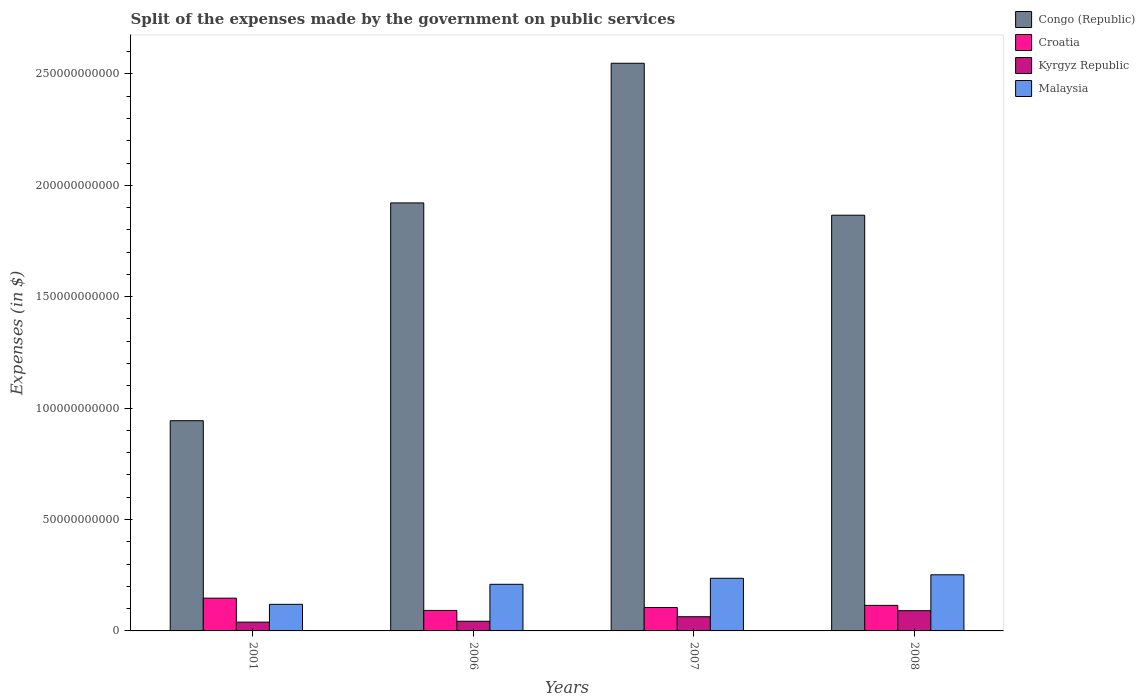Are the number of bars per tick equal to the number of legend labels?
Offer a terse response. Yes. How many bars are there on the 4th tick from the left?
Offer a terse response. 4. How many bars are there on the 2nd tick from the right?
Make the answer very short. 4. What is the expenses made by the government on public services in Congo (Republic) in 2007?
Provide a succinct answer. 2.55e+11. Across all years, what is the maximum expenses made by the government on public services in Malaysia?
Give a very brief answer. 2.52e+1. Across all years, what is the minimum expenses made by the government on public services in Malaysia?
Offer a terse response. 1.19e+1. In which year was the expenses made by the government on public services in Malaysia maximum?
Make the answer very short. 2008. What is the total expenses made by the government on public services in Kyrgyz Republic in the graph?
Provide a succinct answer. 2.37e+1. What is the difference between the expenses made by the government on public services in Congo (Republic) in 2001 and that in 2006?
Give a very brief answer. -9.78e+1. What is the difference between the expenses made by the government on public services in Malaysia in 2001 and the expenses made by the government on public services in Kyrgyz Republic in 2006?
Provide a succinct answer. 7.59e+09. What is the average expenses made by the government on public services in Congo (Republic) per year?
Ensure brevity in your answer.  1.82e+11. In the year 2007, what is the difference between the expenses made by the government on public services in Kyrgyz Republic and expenses made by the government on public services in Congo (Republic)?
Make the answer very short. -2.48e+11. In how many years, is the expenses made by the government on public services in Malaysia greater than 120000000000 $?
Your answer should be compact. 0. What is the ratio of the expenses made by the government on public services in Kyrgyz Republic in 2007 to that in 2008?
Offer a terse response. 0.7. What is the difference between the highest and the second highest expenses made by the government on public services in Kyrgyz Republic?
Offer a very short reply. 2.71e+09. What is the difference between the highest and the lowest expenses made by the government on public services in Croatia?
Offer a very short reply. 5.51e+09. In how many years, is the expenses made by the government on public services in Congo (Republic) greater than the average expenses made by the government on public services in Congo (Republic) taken over all years?
Provide a succinct answer. 3. Is it the case that in every year, the sum of the expenses made by the government on public services in Croatia and expenses made by the government on public services in Malaysia is greater than the sum of expenses made by the government on public services in Congo (Republic) and expenses made by the government on public services in Kyrgyz Republic?
Give a very brief answer. No. What does the 4th bar from the left in 2007 represents?
Your answer should be very brief. Malaysia. What does the 4th bar from the right in 2006 represents?
Keep it short and to the point. Congo (Republic). Is it the case that in every year, the sum of the expenses made by the government on public services in Croatia and expenses made by the government on public services in Kyrgyz Republic is greater than the expenses made by the government on public services in Congo (Republic)?
Offer a terse response. No. How many bars are there?
Offer a very short reply. 16. How many years are there in the graph?
Offer a very short reply. 4. Are the values on the major ticks of Y-axis written in scientific E-notation?
Give a very brief answer. No. Does the graph contain any zero values?
Your response must be concise. No. Where does the legend appear in the graph?
Offer a terse response. Top right. What is the title of the graph?
Offer a terse response. Split of the expenses made by the government on public services. What is the label or title of the Y-axis?
Offer a very short reply. Expenses (in $). What is the Expenses (in $) of Congo (Republic) in 2001?
Provide a short and direct response. 9.43e+1. What is the Expenses (in $) in Croatia in 2001?
Your answer should be compact. 1.47e+1. What is the Expenses (in $) in Kyrgyz Republic in 2001?
Offer a terse response. 3.95e+09. What is the Expenses (in $) of Malaysia in 2001?
Offer a very short reply. 1.19e+1. What is the Expenses (in $) of Congo (Republic) in 2006?
Ensure brevity in your answer.  1.92e+11. What is the Expenses (in $) of Croatia in 2006?
Offer a very short reply. 9.19e+09. What is the Expenses (in $) in Kyrgyz Republic in 2006?
Give a very brief answer. 4.35e+09. What is the Expenses (in $) in Malaysia in 2006?
Offer a terse response. 2.09e+1. What is the Expenses (in $) in Congo (Republic) in 2007?
Make the answer very short. 2.55e+11. What is the Expenses (in $) in Croatia in 2007?
Your response must be concise. 1.05e+1. What is the Expenses (in $) in Kyrgyz Republic in 2007?
Provide a short and direct response. 6.37e+09. What is the Expenses (in $) in Malaysia in 2007?
Your answer should be very brief. 2.36e+1. What is the Expenses (in $) of Congo (Republic) in 2008?
Provide a succinct answer. 1.87e+11. What is the Expenses (in $) in Croatia in 2008?
Keep it short and to the point. 1.15e+1. What is the Expenses (in $) of Kyrgyz Republic in 2008?
Offer a very short reply. 9.08e+09. What is the Expenses (in $) in Malaysia in 2008?
Your response must be concise. 2.52e+1. Across all years, what is the maximum Expenses (in $) of Congo (Republic)?
Your answer should be compact. 2.55e+11. Across all years, what is the maximum Expenses (in $) of Croatia?
Make the answer very short. 1.47e+1. Across all years, what is the maximum Expenses (in $) in Kyrgyz Republic?
Make the answer very short. 9.08e+09. Across all years, what is the maximum Expenses (in $) in Malaysia?
Make the answer very short. 2.52e+1. Across all years, what is the minimum Expenses (in $) in Congo (Republic)?
Keep it short and to the point. 9.43e+1. Across all years, what is the minimum Expenses (in $) in Croatia?
Offer a terse response. 9.19e+09. Across all years, what is the minimum Expenses (in $) of Kyrgyz Republic?
Give a very brief answer. 3.95e+09. Across all years, what is the minimum Expenses (in $) in Malaysia?
Provide a short and direct response. 1.19e+1. What is the total Expenses (in $) in Congo (Republic) in the graph?
Ensure brevity in your answer.  7.28e+11. What is the total Expenses (in $) of Croatia in the graph?
Ensure brevity in your answer.  4.59e+1. What is the total Expenses (in $) in Kyrgyz Republic in the graph?
Provide a short and direct response. 2.37e+1. What is the total Expenses (in $) in Malaysia in the graph?
Give a very brief answer. 8.17e+1. What is the difference between the Expenses (in $) in Congo (Republic) in 2001 and that in 2006?
Your answer should be very brief. -9.78e+1. What is the difference between the Expenses (in $) in Croatia in 2001 and that in 2006?
Provide a short and direct response. 5.51e+09. What is the difference between the Expenses (in $) in Kyrgyz Republic in 2001 and that in 2006?
Offer a very short reply. -4.01e+08. What is the difference between the Expenses (in $) of Malaysia in 2001 and that in 2006?
Provide a short and direct response. -8.99e+09. What is the difference between the Expenses (in $) of Congo (Republic) in 2001 and that in 2007?
Provide a succinct answer. -1.60e+11. What is the difference between the Expenses (in $) of Croatia in 2001 and that in 2007?
Ensure brevity in your answer.  4.18e+09. What is the difference between the Expenses (in $) in Kyrgyz Republic in 2001 and that in 2007?
Ensure brevity in your answer.  -2.42e+09. What is the difference between the Expenses (in $) of Malaysia in 2001 and that in 2007?
Your answer should be compact. -1.17e+1. What is the difference between the Expenses (in $) of Congo (Republic) in 2001 and that in 2008?
Make the answer very short. -9.22e+1. What is the difference between the Expenses (in $) of Croatia in 2001 and that in 2008?
Offer a terse response. 3.23e+09. What is the difference between the Expenses (in $) in Kyrgyz Republic in 2001 and that in 2008?
Offer a very short reply. -5.13e+09. What is the difference between the Expenses (in $) in Malaysia in 2001 and that in 2008?
Your response must be concise. -1.33e+1. What is the difference between the Expenses (in $) of Congo (Republic) in 2006 and that in 2007?
Provide a short and direct response. -6.27e+1. What is the difference between the Expenses (in $) of Croatia in 2006 and that in 2007?
Provide a succinct answer. -1.32e+09. What is the difference between the Expenses (in $) of Kyrgyz Republic in 2006 and that in 2007?
Offer a terse response. -2.02e+09. What is the difference between the Expenses (in $) in Malaysia in 2006 and that in 2007?
Keep it short and to the point. -2.70e+09. What is the difference between the Expenses (in $) in Congo (Republic) in 2006 and that in 2008?
Make the answer very short. 5.52e+09. What is the difference between the Expenses (in $) in Croatia in 2006 and that in 2008?
Keep it short and to the point. -2.27e+09. What is the difference between the Expenses (in $) in Kyrgyz Republic in 2006 and that in 2008?
Make the answer very short. -4.73e+09. What is the difference between the Expenses (in $) in Malaysia in 2006 and that in 2008?
Your answer should be very brief. -4.27e+09. What is the difference between the Expenses (in $) in Congo (Republic) in 2007 and that in 2008?
Give a very brief answer. 6.82e+1. What is the difference between the Expenses (in $) of Croatia in 2007 and that in 2008?
Offer a terse response. -9.51e+08. What is the difference between the Expenses (in $) of Kyrgyz Republic in 2007 and that in 2008?
Keep it short and to the point. -2.71e+09. What is the difference between the Expenses (in $) in Malaysia in 2007 and that in 2008?
Your response must be concise. -1.57e+09. What is the difference between the Expenses (in $) in Congo (Republic) in 2001 and the Expenses (in $) in Croatia in 2006?
Your response must be concise. 8.52e+1. What is the difference between the Expenses (in $) of Congo (Republic) in 2001 and the Expenses (in $) of Kyrgyz Republic in 2006?
Offer a terse response. 9.00e+1. What is the difference between the Expenses (in $) of Congo (Republic) in 2001 and the Expenses (in $) of Malaysia in 2006?
Your answer should be very brief. 7.34e+1. What is the difference between the Expenses (in $) of Croatia in 2001 and the Expenses (in $) of Kyrgyz Republic in 2006?
Ensure brevity in your answer.  1.04e+1. What is the difference between the Expenses (in $) of Croatia in 2001 and the Expenses (in $) of Malaysia in 2006?
Ensure brevity in your answer.  -6.22e+09. What is the difference between the Expenses (in $) in Kyrgyz Republic in 2001 and the Expenses (in $) in Malaysia in 2006?
Make the answer very short. -1.70e+1. What is the difference between the Expenses (in $) of Congo (Republic) in 2001 and the Expenses (in $) of Croatia in 2007?
Your answer should be very brief. 8.38e+1. What is the difference between the Expenses (in $) of Congo (Republic) in 2001 and the Expenses (in $) of Kyrgyz Republic in 2007?
Your answer should be very brief. 8.80e+1. What is the difference between the Expenses (in $) of Congo (Republic) in 2001 and the Expenses (in $) of Malaysia in 2007?
Your response must be concise. 7.07e+1. What is the difference between the Expenses (in $) of Croatia in 2001 and the Expenses (in $) of Kyrgyz Republic in 2007?
Offer a terse response. 8.33e+09. What is the difference between the Expenses (in $) in Croatia in 2001 and the Expenses (in $) in Malaysia in 2007?
Give a very brief answer. -8.92e+09. What is the difference between the Expenses (in $) in Kyrgyz Republic in 2001 and the Expenses (in $) in Malaysia in 2007?
Make the answer very short. -1.97e+1. What is the difference between the Expenses (in $) in Congo (Republic) in 2001 and the Expenses (in $) in Croatia in 2008?
Ensure brevity in your answer.  8.29e+1. What is the difference between the Expenses (in $) in Congo (Republic) in 2001 and the Expenses (in $) in Kyrgyz Republic in 2008?
Give a very brief answer. 8.53e+1. What is the difference between the Expenses (in $) in Congo (Republic) in 2001 and the Expenses (in $) in Malaysia in 2008?
Your response must be concise. 6.92e+1. What is the difference between the Expenses (in $) in Croatia in 2001 and the Expenses (in $) in Kyrgyz Republic in 2008?
Offer a terse response. 5.62e+09. What is the difference between the Expenses (in $) of Croatia in 2001 and the Expenses (in $) of Malaysia in 2008?
Ensure brevity in your answer.  -1.05e+1. What is the difference between the Expenses (in $) of Kyrgyz Republic in 2001 and the Expenses (in $) of Malaysia in 2008?
Make the answer very short. -2.13e+1. What is the difference between the Expenses (in $) of Congo (Republic) in 2006 and the Expenses (in $) of Croatia in 2007?
Provide a succinct answer. 1.82e+11. What is the difference between the Expenses (in $) in Congo (Republic) in 2006 and the Expenses (in $) in Kyrgyz Republic in 2007?
Ensure brevity in your answer.  1.86e+11. What is the difference between the Expenses (in $) of Congo (Republic) in 2006 and the Expenses (in $) of Malaysia in 2007?
Make the answer very short. 1.68e+11. What is the difference between the Expenses (in $) in Croatia in 2006 and the Expenses (in $) in Kyrgyz Republic in 2007?
Your answer should be compact. 2.82e+09. What is the difference between the Expenses (in $) in Croatia in 2006 and the Expenses (in $) in Malaysia in 2007?
Keep it short and to the point. -1.44e+1. What is the difference between the Expenses (in $) of Kyrgyz Republic in 2006 and the Expenses (in $) of Malaysia in 2007?
Make the answer very short. -1.93e+1. What is the difference between the Expenses (in $) in Congo (Republic) in 2006 and the Expenses (in $) in Croatia in 2008?
Offer a terse response. 1.81e+11. What is the difference between the Expenses (in $) of Congo (Republic) in 2006 and the Expenses (in $) of Kyrgyz Republic in 2008?
Ensure brevity in your answer.  1.83e+11. What is the difference between the Expenses (in $) in Congo (Republic) in 2006 and the Expenses (in $) in Malaysia in 2008?
Provide a short and direct response. 1.67e+11. What is the difference between the Expenses (in $) in Croatia in 2006 and the Expenses (in $) in Kyrgyz Republic in 2008?
Your answer should be very brief. 1.14e+08. What is the difference between the Expenses (in $) of Croatia in 2006 and the Expenses (in $) of Malaysia in 2008?
Your answer should be compact. -1.60e+1. What is the difference between the Expenses (in $) of Kyrgyz Republic in 2006 and the Expenses (in $) of Malaysia in 2008?
Your answer should be very brief. -2.08e+1. What is the difference between the Expenses (in $) of Congo (Republic) in 2007 and the Expenses (in $) of Croatia in 2008?
Provide a short and direct response. 2.43e+11. What is the difference between the Expenses (in $) of Congo (Republic) in 2007 and the Expenses (in $) of Kyrgyz Republic in 2008?
Your response must be concise. 2.46e+11. What is the difference between the Expenses (in $) in Congo (Republic) in 2007 and the Expenses (in $) in Malaysia in 2008?
Provide a succinct answer. 2.30e+11. What is the difference between the Expenses (in $) in Croatia in 2007 and the Expenses (in $) in Kyrgyz Republic in 2008?
Make the answer very short. 1.44e+09. What is the difference between the Expenses (in $) of Croatia in 2007 and the Expenses (in $) of Malaysia in 2008?
Offer a terse response. -1.47e+1. What is the difference between the Expenses (in $) in Kyrgyz Republic in 2007 and the Expenses (in $) in Malaysia in 2008?
Your answer should be very brief. -1.88e+1. What is the average Expenses (in $) in Congo (Republic) per year?
Provide a succinct answer. 1.82e+11. What is the average Expenses (in $) of Croatia per year?
Ensure brevity in your answer.  1.15e+1. What is the average Expenses (in $) in Kyrgyz Republic per year?
Provide a short and direct response. 5.94e+09. What is the average Expenses (in $) in Malaysia per year?
Offer a terse response. 2.04e+1. In the year 2001, what is the difference between the Expenses (in $) of Congo (Republic) and Expenses (in $) of Croatia?
Provide a succinct answer. 7.96e+1. In the year 2001, what is the difference between the Expenses (in $) in Congo (Republic) and Expenses (in $) in Kyrgyz Republic?
Ensure brevity in your answer.  9.04e+1. In the year 2001, what is the difference between the Expenses (in $) in Congo (Republic) and Expenses (in $) in Malaysia?
Make the answer very short. 8.24e+1. In the year 2001, what is the difference between the Expenses (in $) in Croatia and Expenses (in $) in Kyrgyz Republic?
Your answer should be compact. 1.08e+1. In the year 2001, what is the difference between the Expenses (in $) of Croatia and Expenses (in $) of Malaysia?
Ensure brevity in your answer.  2.76e+09. In the year 2001, what is the difference between the Expenses (in $) in Kyrgyz Republic and Expenses (in $) in Malaysia?
Your answer should be very brief. -7.99e+09. In the year 2006, what is the difference between the Expenses (in $) in Congo (Republic) and Expenses (in $) in Croatia?
Provide a succinct answer. 1.83e+11. In the year 2006, what is the difference between the Expenses (in $) of Congo (Republic) and Expenses (in $) of Kyrgyz Republic?
Your response must be concise. 1.88e+11. In the year 2006, what is the difference between the Expenses (in $) in Congo (Republic) and Expenses (in $) in Malaysia?
Your response must be concise. 1.71e+11. In the year 2006, what is the difference between the Expenses (in $) in Croatia and Expenses (in $) in Kyrgyz Republic?
Keep it short and to the point. 4.85e+09. In the year 2006, what is the difference between the Expenses (in $) of Croatia and Expenses (in $) of Malaysia?
Your response must be concise. -1.17e+1. In the year 2006, what is the difference between the Expenses (in $) of Kyrgyz Republic and Expenses (in $) of Malaysia?
Make the answer very short. -1.66e+1. In the year 2007, what is the difference between the Expenses (in $) in Congo (Republic) and Expenses (in $) in Croatia?
Your answer should be compact. 2.44e+11. In the year 2007, what is the difference between the Expenses (in $) in Congo (Republic) and Expenses (in $) in Kyrgyz Republic?
Your answer should be compact. 2.48e+11. In the year 2007, what is the difference between the Expenses (in $) in Congo (Republic) and Expenses (in $) in Malaysia?
Offer a terse response. 2.31e+11. In the year 2007, what is the difference between the Expenses (in $) in Croatia and Expenses (in $) in Kyrgyz Republic?
Ensure brevity in your answer.  4.15e+09. In the year 2007, what is the difference between the Expenses (in $) of Croatia and Expenses (in $) of Malaysia?
Provide a short and direct response. -1.31e+1. In the year 2007, what is the difference between the Expenses (in $) of Kyrgyz Republic and Expenses (in $) of Malaysia?
Give a very brief answer. -1.73e+1. In the year 2008, what is the difference between the Expenses (in $) in Congo (Republic) and Expenses (in $) in Croatia?
Offer a terse response. 1.75e+11. In the year 2008, what is the difference between the Expenses (in $) of Congo (Republic) and Expenses (in $) of Kyrgyz Republic?
Give a very brief answer. 1.78e+11. In the year 2008, what is the difference between the Expenses (in $) of Congo (Republic) and Expenses (in $) of Malaysia?
Provide a succinct answer. 1.61e+11. In the year 2008, what is the difference between the Expenses (in $) of Croatia and Expenses (in $) of Kyrgyz Republic?
Provide a short and direct response. 2.39e+09. In the year 2008, what is the difference between the Expenses (in $) of Croatia and Expenses (in $) of Malaysia?
Offer a terse response. -1.37e+1. In the year 2008, what is the difference between the Expenses (in $) in Kyrgyz Republic and Expenses (in $) in Malaysia?
Offer a very short reply. -1.61e+1. What is the ratio of the Expenses (in $) of Congo (Republic) in 2001 to that in 2006?
Make the answer very short. 0.49. What is the ratio of the Expenses (in $) of Croatia in 2001 to that in 2006?
Your response must be concise. 1.6. What is the ratio of the Expenses (in $) in Kyrgyz Republic in 2001 to that in 2006?
Offer a very short reply. 0.91. What is the ratio of the Expenses (in $) of Malaysia in 2001 to that in 2006?
Your response must be concise. 0.57. What is the ratio of the Expenses (in $) of Congo (Republic) in 2001 to that in 2007?
Provide a succinct answer. 0.37. What is the ratio of the Expenses (in $) in Croatia in 2001 to that in 2007?
Offer a terse response. 1.4. What is the ratio of the Expenses (in $) of Kyrgyz Republic in 2001 to that in 2007?
Give a very brief answer. 0.62. What is the ratio of the Expenses (in $) in Malaysia in 2001 to that in 2007?
Provide a short and direct response. 0.51. What is the ratio of the Expenses (in $) of Congo (Republic) in 2001 to that in 2008?
Offer a very short reply. 0.51. What is the ratio of the Expenses (in $) in Croatia in 2001 to that in 2008?
Make the answer very short. 1.28. What is the ratio of the Expenses (in $) of Kyrgyz Republic in 2001 to that in 2008?
Make the answer very short. 0.43. What is the ratio of the Expenses (in $) in Malaysia in 2001 to that in 2008?
Provide a short and direct response. 0.47. What is the ratio of the Expenses (in $) of Congo (Republic) in 2006 to that in 2007?
Your answer should be very brief. 0.75. What is the ratio of the Expenses (in $) in Croatia in 2006 to that in 2007?
Keep it short and to the point. 0.87. What is the ratio of the Expenses (in $) in Kyrgyz Republic in 2006 to that in 2007?
Make the answer very short. 0.68. What is the ratio of the Expenses (in $) in Malaysia in 2006 to that in 2007?
Ensure brevity in your answer.  0.89. What is the ratio of the Expenses (in $) in Congo (Republic) in 2006 to that in 2008?
Offer a very short reply. 1.03. What is the ratio of the Expenses (in $) of Croatia in 2006 to that in 2008?
Offer a very short reply. 0.8. What is the ratio of the Expenses (in $) in Kyrgyz Republic in 2006 to that in 2008?
Offer a terse response. 0.48. What is the ratio of the Expenses (in $) in Malaysia in 2006 to that in 2008?
Your answer should be compact. 0.83. What is the ratio of the Expenses (in $) of Congo (Republic) in 2007 to that in 2008?
Provide a succinct answer. 1.37. What is the ratio of the Expenses (in $) of Croatia in 2007 to that in 2008?
Give a very brief answer. 0.92. What is the ratio of the Expenses (in $) in Kyrgyz Republic in 2007 to that in 2008?
Ensure brevity in your answer.  0.7. What is the ratio of the Expenses (in $) in Malaysia in 2007 to that in 2008?
Your response must be concise. 0.94. What is the difference between the highest and the second highest Expenses (in $) of Congo (Republic)?
Your response must be concise. 6.27e+1. What is the difference between the highest and the second highest Expenses (in $) in Croatia?
Make the answer very short. 3.23e+09. What is the difference between the highest and the second highest Expenses (in $) in Kyrgyz Republic?
Your answer should be compact. 2.71e+09. What is the difference between the highest and the second highest Expenses (in $) in Malaysia?
Offer a very short reply. 1.57e+09. What is the difference between the highest and the lowest Expenses (in $) of Congo (Republic)?
Provide a succinct answer. 1.60e+11. What is the difference between the highest and the lowest Expenses (in $) of Croatia?
Your answer should be very brief. 5.51e+09. What is the difference between the highest and the lowest Expenses (in $) of Kyrgyz Republic?
Your response must be concise. 5.13e+09. What is the difference between the highest and the lowest Expenses (in $) of Malaysia?
Your answer should be compact. 1.33e+1. 